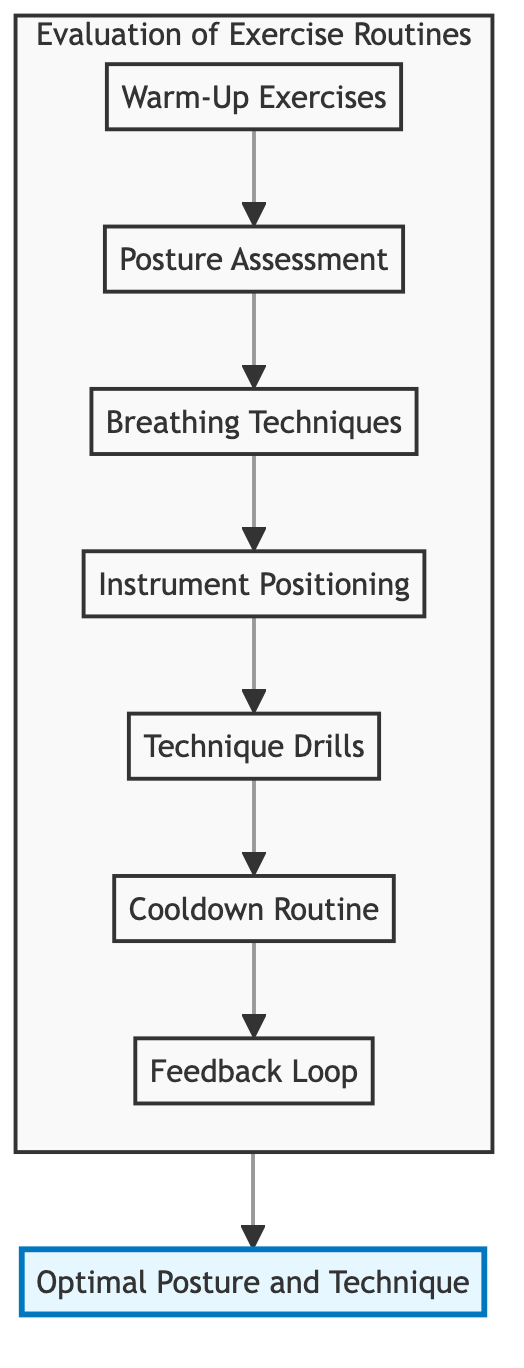What is the first element in the flow chart? The first element in the flow chart is "Warm-Up Exercises," as it is the starting point that leads to subsequent nodes.
Answer: Warm-Up Exercises How many elements are in the evaluation process? The flow chart displays a total of seven elements, ranging from "Warm-Up Exercises" to "Feedback Loop."
Answer: Seven What comes after "Posture Assessment"? In the flow chart, "Breathing Techniques" comes after "Posture Assessment," indicating the sequential flow from one activity to the next.
Answer: Breathing Techniques Which element focuses on relaxation exercises? The element that focuses on relaxation exercises is "Cooldown Routine," as it specifically describes stretching and relaxation techniques.
Answer: Cooldown Routine What is the ultimate goal of the evaluation process? The ultimate goal, indicated at the end of the flow chart, is "Optimal Posture and Technique," which encompasses the results of all previous activities.
Answer: Optimal Posture and Technique How does "Instrument Positioning" relate to "Technique Drills"? "Instrument Positioning" directly leads into "Technique Drills," showing that the proper positioning is a prerequisite before performing technique drills.
Answer: Instrument Positioning leads to Technique Drills Which element incorporates self-awareness? "Feedback Loop" is the element that incorporates self-awareness, as it involves regular feedback sessions for self-evaluation of posture and technique.
Answer: Feedback Loop What type of exercises are included in "Warm-Up Exercises"? "Warm-Up Exercises" includes gentle stretching and mobility exercises specific to musicians, designed for preparation before playing.
Answer: Gentle stretching and mobility exercises What color represents the "Cooldown Routine" in the diagram? "Cooldown Routine" is represented in a light pink color with a stroke of a darker pink in the flow chart, distinguishing it visually from other elements.
Answer: Light pink Which node indicates the need for height and angle adjustments? "Instrument Positioning" indicates the need for proper height and angle adjustments of instruments to support optimal posture during play.
Answer: Instrument Positioning 